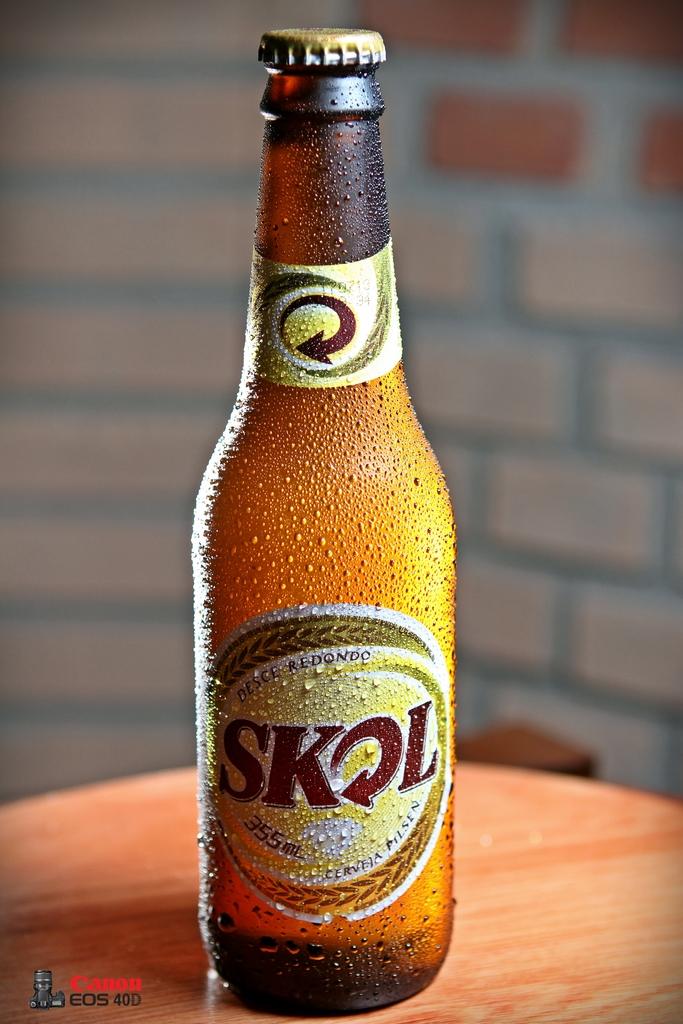What brand is this drink?
Give a very brief answer. Skol. What drink is this?
Make the answer very short. Skol. 